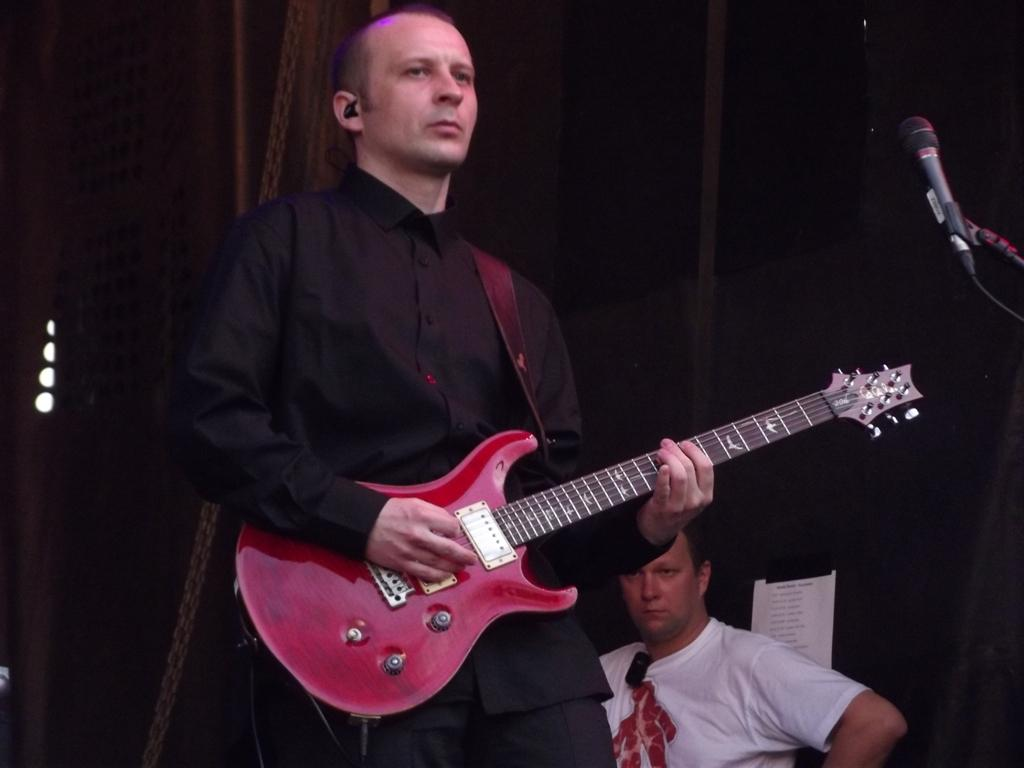What is the man in the image doing? The man is standing in the image and holding a guitar. What can be seen in the background of the image? There is a background in the image, and another person is visible in the background. What object is the man likely to use while playing the guitar? There is a microphone (mic) visible in the image, which the man might use while playing the guitar. What type of toys can be seen scattered around the man in the image? There are no toys visible in the image; the man is holding a guitar and standing in front of a microphone. 